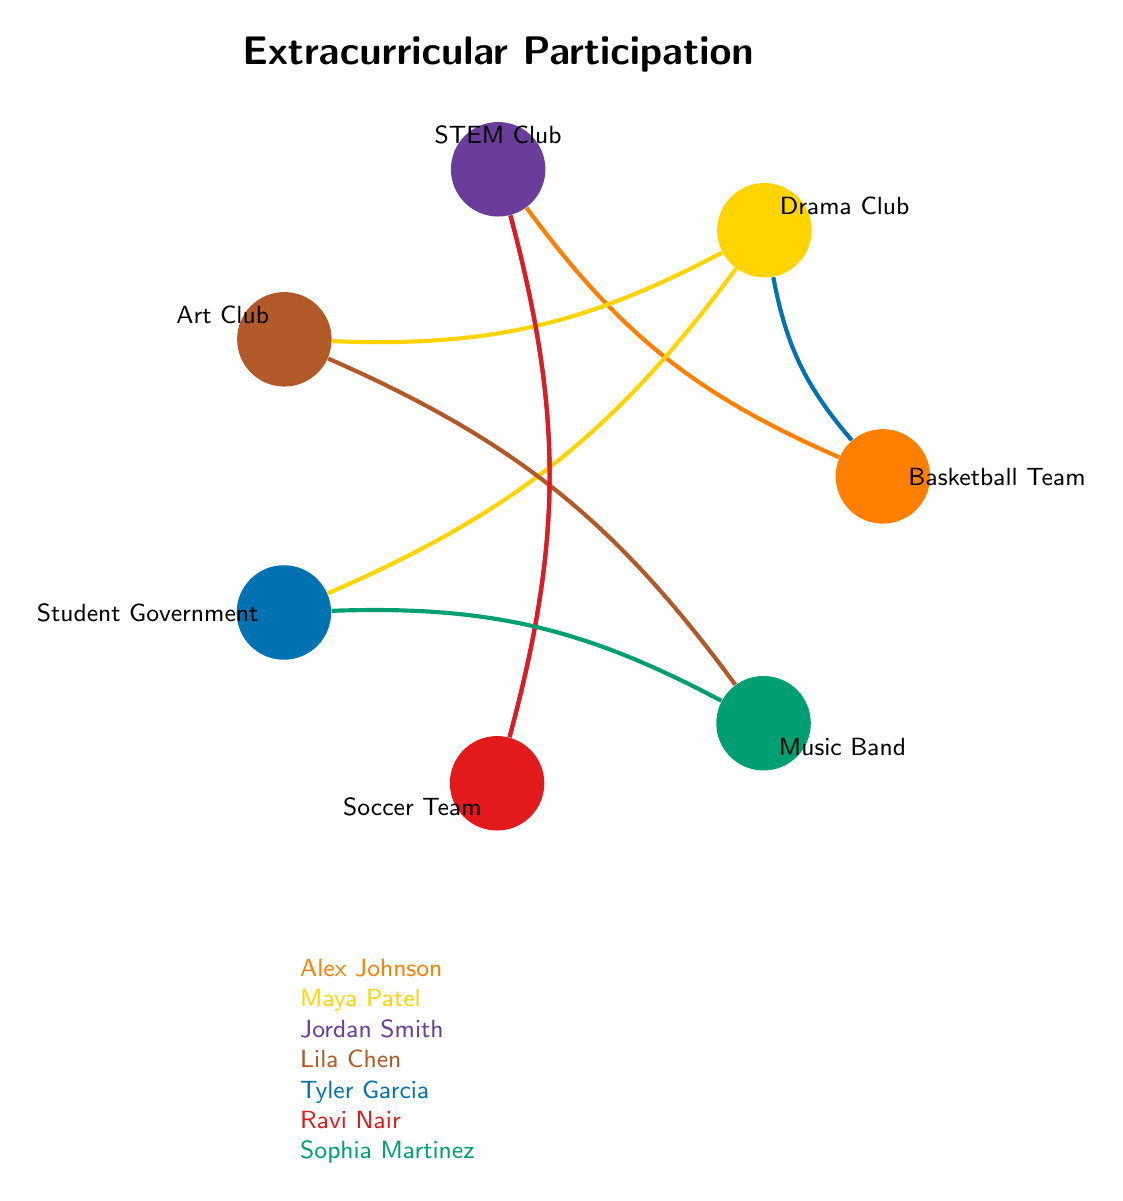What extracurricular activities does Alex Johnson participate in? From the diagram, we can see that Alex Johnson is connected to the Basketball Team and the STEM Club based on the lines drawn from the respective nodes.
Answer: Basketball Team, STEM Club How many students are involved in the Drama Club? By looking at the connections, we can see that Maya Patel and Tyler Garcia both have lines connecting them to the Drama Club node, indicating their participation.
Answer: 2 Which student participates in both the Soccer Team and STEM Club? Observing the lines from the Soccer Team node and the STEM Club node, we can see that Ravi Nair has connections to both activities, indicating his participation in both.
Answer: Ravi Nair What is the total number of extracurricular activities represented in the diagram? Counting the number of labeled activity nodes in the diagram gives us a total of 7 distinct activities displayed.
Answer: 7 Which activity has the most connections to students? By analyzing the connections, we find that the STEM Club is linked to three students: Alex Johnson, Jordan Smith, and Ravi Nair. This is more than any other activity shown in the diagram.
Answer: STEM Club How many students participate in the Music Band? Examining the connection to the Music Band node, we see that it is connected to Lila Chen and Sophia Martinez, indicating that two students participate in this activity.
Answer: 2 Which student is involved in both a sports team and a club? By checking the connections, we see that Alex Johnson is involved in the Basketball Team (sports) and the STEM Club (club), fitting the criteria.
Answer: Alex Johnson Which two activities are connected to the most students overall? By observing the connections, the STEM Club (connected to Alex Johnson, Jordan Smith, and Ravi Nair) and the Drama Club (connected to Maya Patel and Tyler Garcia) are the two activities with the highest participation, with a total of 5 individual student connections between them.
Answer: STEM Club, Drama Club 